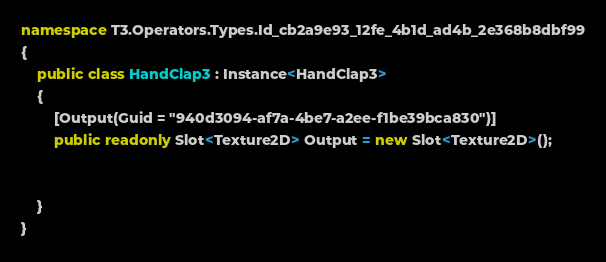<code> <loc_0><loc_0><loc_500><loc_500><_C#_>
namespace T3.Operators.Types.Id_cb2a9e93_12fe_4b1d_ad4b_2e368b8dbf99
{
    public class HandClap3 : Instance<HandClap3>
    {
        [Output(Guid = "940d3094-af7a-4be7-a2ee-f1be39bca830")]
        public readonly Slot<Texture2D> Output = new Slot<Texture2D>();


    }
}

</code> 